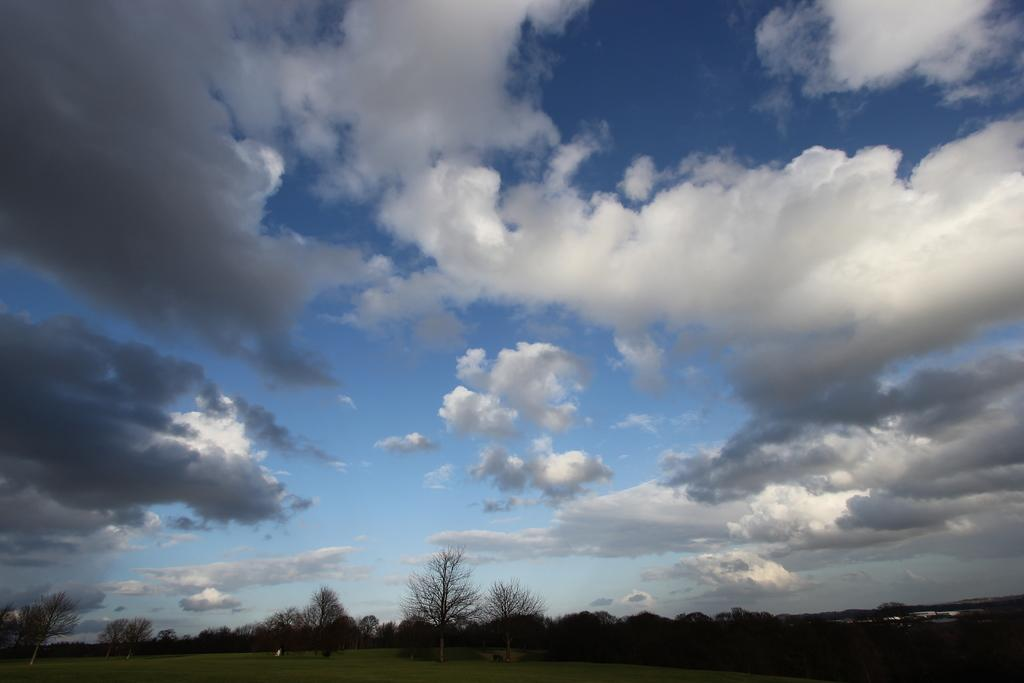What can be seen at the top of the image? The sky is visible in the image. What is present in the sky? There are clouds in the sky. What type of vegetation is at the bottom of the image? Trees are present at the bottom of the image. What covers the ground at the bottom of the image? Grass is on the ground at the bottom of the image. How many minutes does it take for the needle to sew through the fabric in the image? There is no needle or fabric present in the image, so it is not possible to answer that question. 